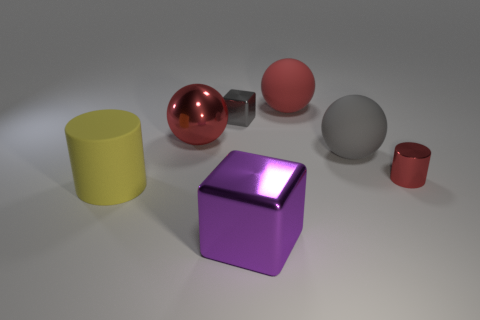Add 3 large rubber balls. How many objects exist? 10 Subtract all balls. How many objects are left? 4 Subtract all gray cubes. Subtract all large metal balls. How many objects are left? 5 Add 7 large yellow matte things. How many large yellow matte things are left? 8 Add 1 green matte objects. How many green matte objects exist? 1 Subtract 0 green spheres. How many objects are left? 7 